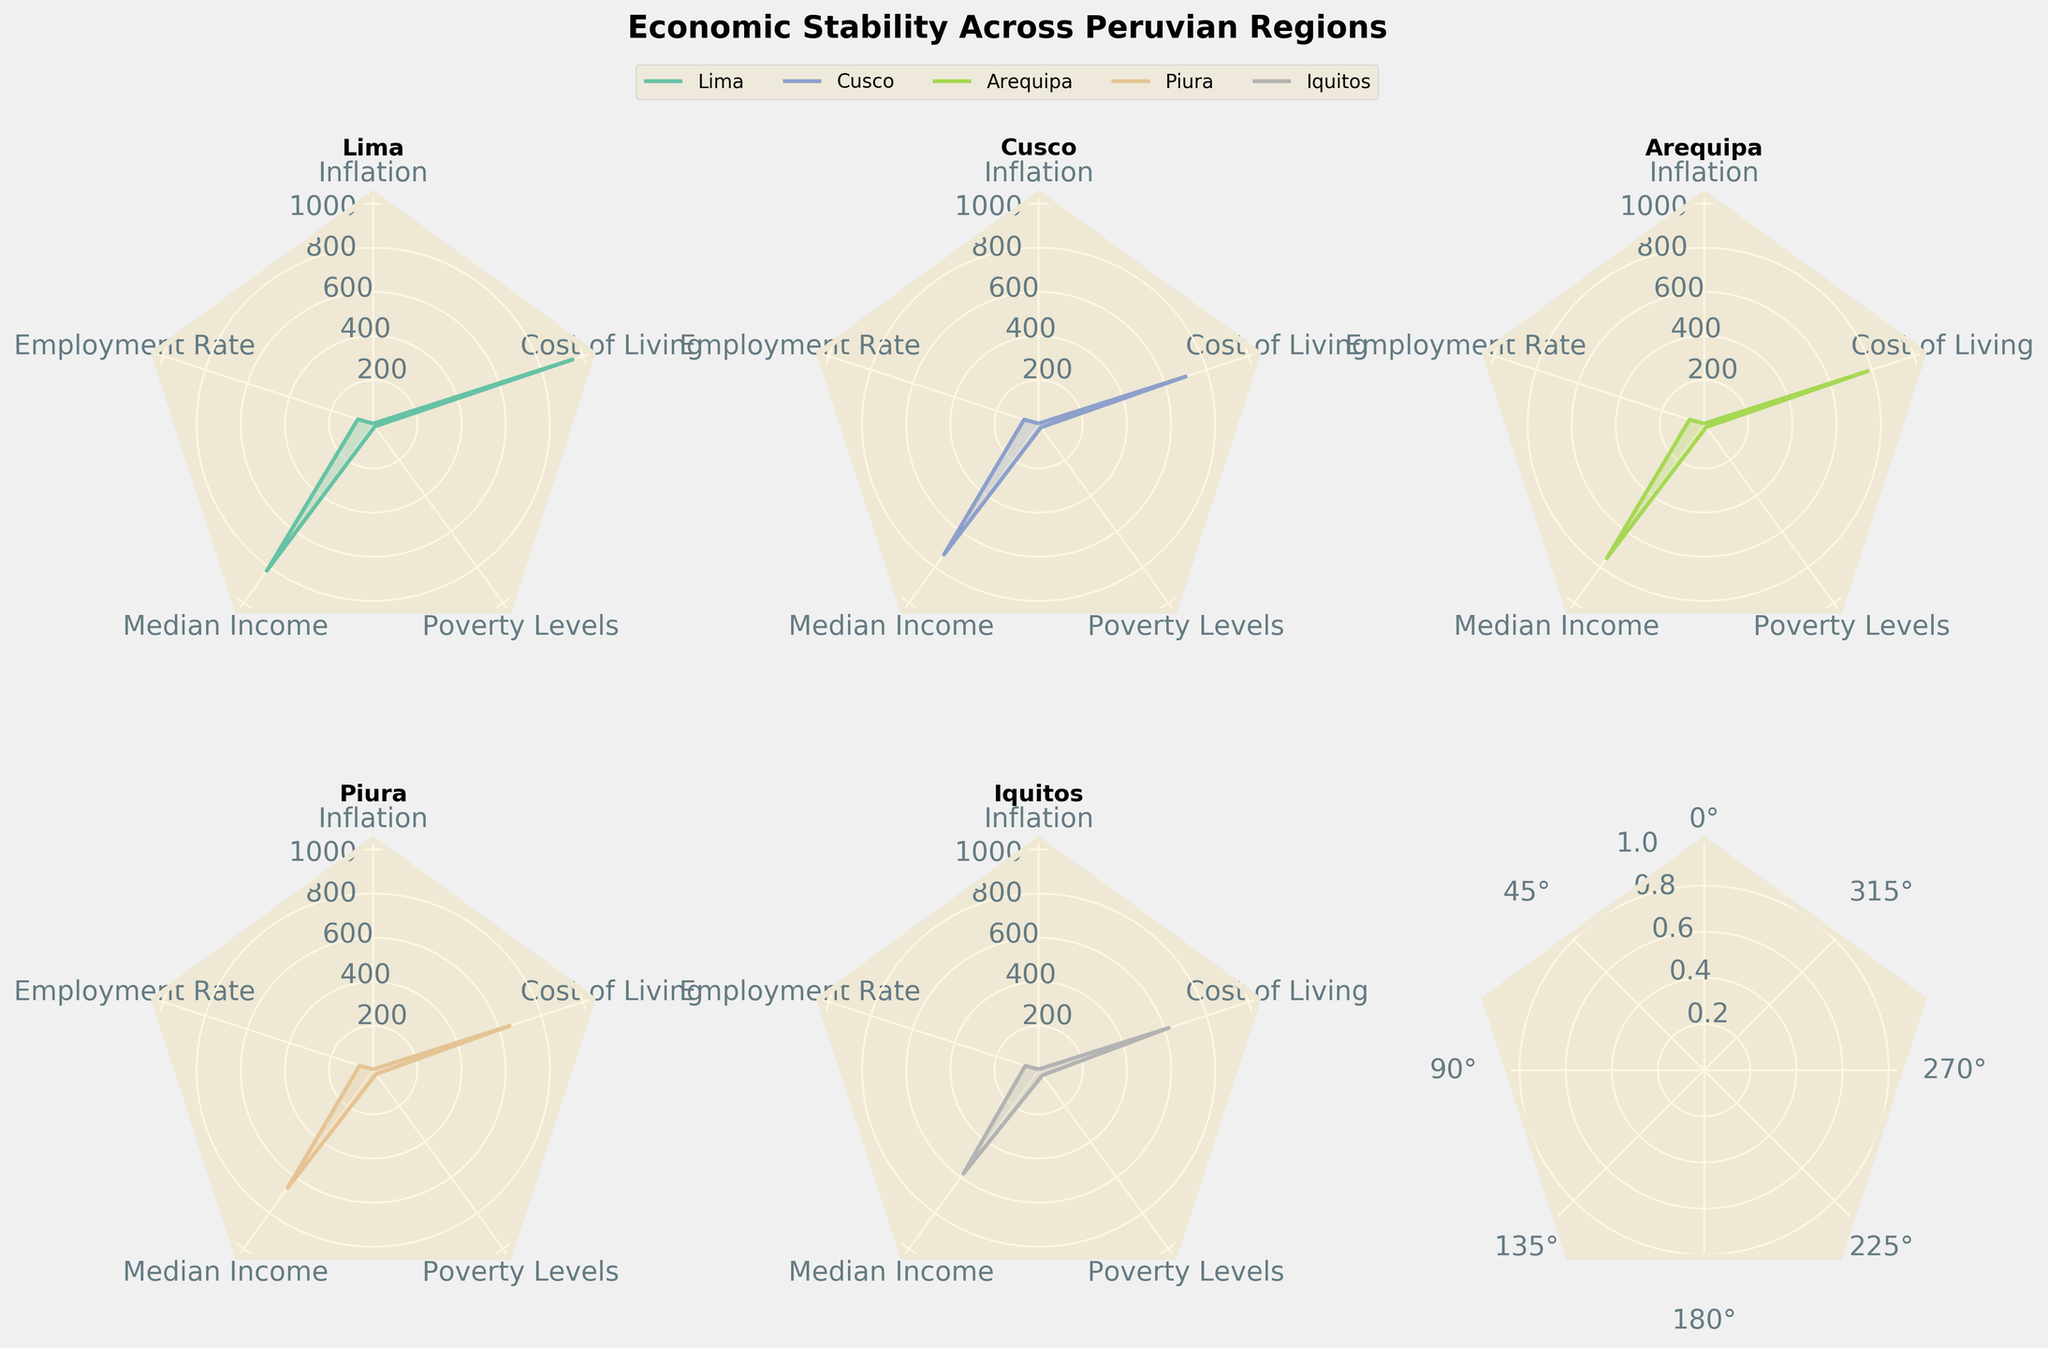What is the median income in Cusco? Look at the radar chart for the Cusco region. The median income data point is marked with a value of 730.00.
Answer: 730.00 Which region has the highest cost of living? Examine each subplot for the cost of living metric. Lima has the highest value with 950.00.
Answer: Lima How do the inflation rates in Piura and Iquitos compare? Refer to the data points for the inflation metric in the subplots corresponding to Piura and Iquitos. Piura has a value of 4.1, while Iquitos has a value of 4.0. Piura's inflation rate is slightly higher.
Answer: Piura's inflation is higher What is the difference in employment rates between Lima and Arequipa? Find the employment rates in the subplots for Lima and Arequipa. Lima has an employment rate of 73.2, and Arequipa has 68.9. The difference is 73.2 - 68.9.
Answer: 4.3 Which region has the lowest poverty level? Check the subplots for the poverty levels in each region. Lima has the lowest poverty level with 12.2.
Answer: Lima What is the combined cost of living for Piura and Iquitos? Locate the cost of living values for Piura and Iquitos in their respective subplots. Piura is 650.00 and Iquitos is 620.00. The total is 650.00 + 620.00.
Answer: 1270.00 How does the employment rate in Cusco compare to Piura? Find the employment rates for Cusco and Piura in their respective subplots. Cusco is at 69.5 and Piura at 65.4. Cusco's employment rate is higher.
Answer: Cusco's employment is higher What are the poverty levels in Arequipa and how does it compare to Iquitos? Check the poverty levels in the subplots for Arequipa and Iquitos. Arequipa has a poverty level of 15.9 and Iquitos has 28.7. Arequipa's poverty level is significantly lower.
Answer: Arequipa's poverty is lower Which region has the lowest median income, and what is it? Look at the subplots for the median income metric. Iquitos has the lowest median income with a value of 580.00.
Answer: Iquitos, 580.00 How much higher is Lima's cost of living compared to Arequipa? Check the cost of living values for Lima and Arequipa. Lima's value is 950.00 while Arequipa's is 780.00. The difference is 950.00 - 780.00.
Answer: 170.00 